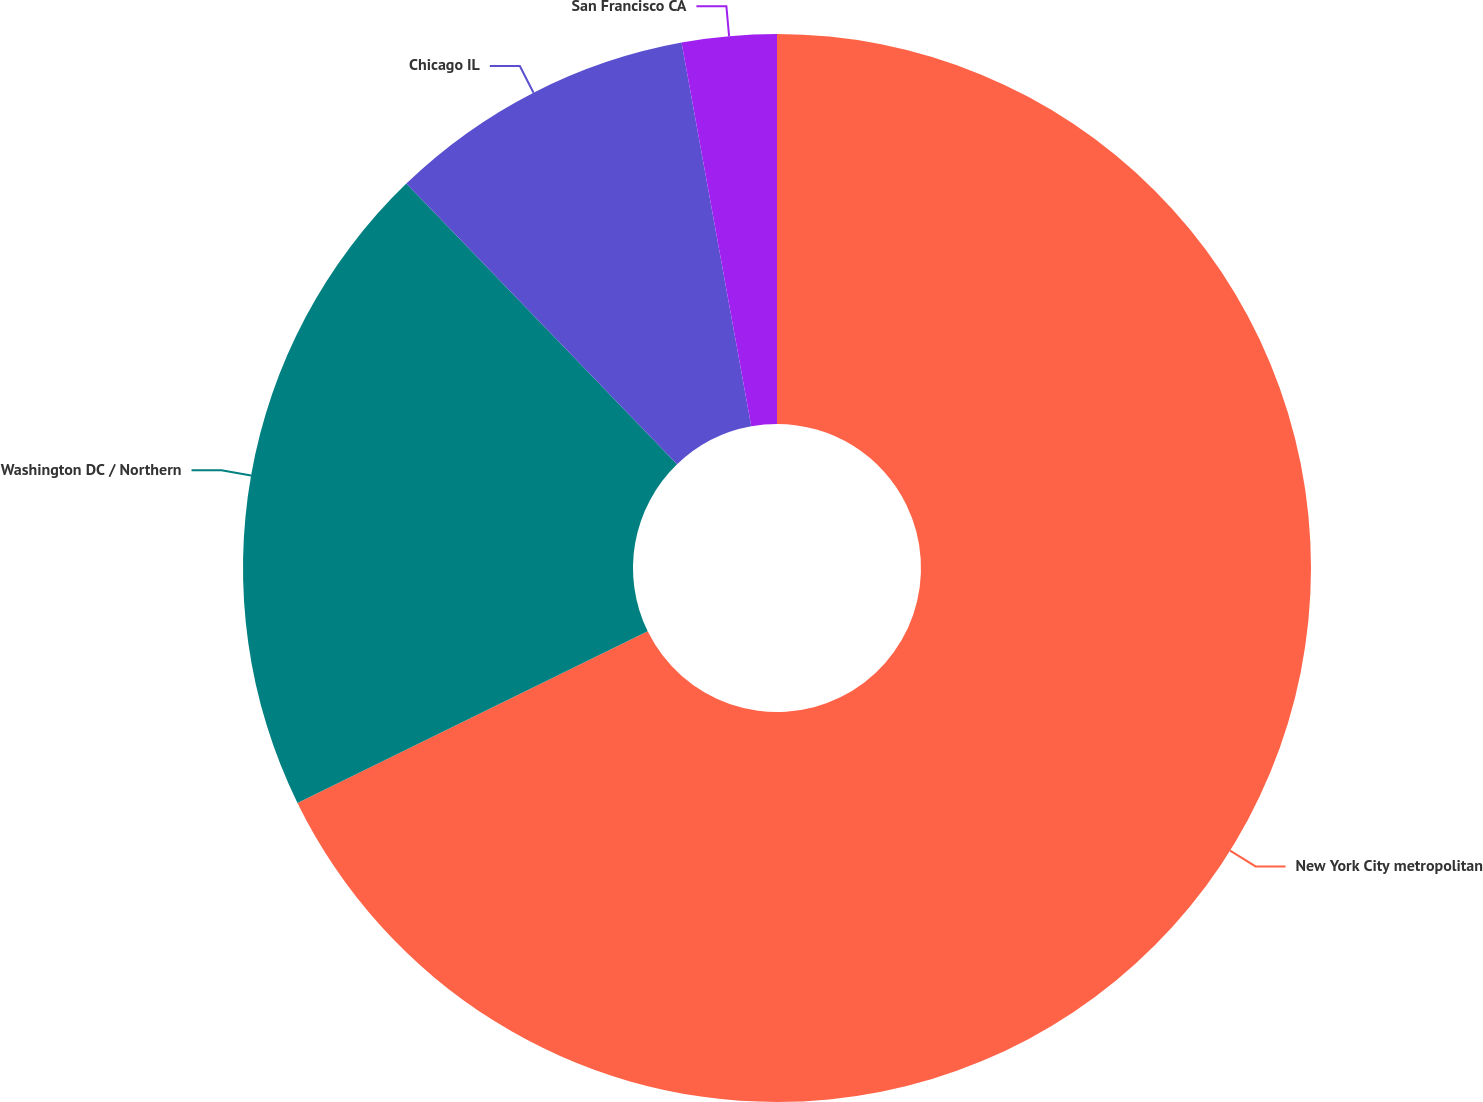Convert chart. <chart><loc_0><loc_0><loc_500><loc_500><pie_chart><fcel>New York City metropolitan<fcel>Washington DC / Northern<fcel>Chicago IL<fcel>San Francisco CA<nl><fcel>67.75%<fcel>20.04%<fcel>9.35%<fcel>2.86%<nl></chart> 